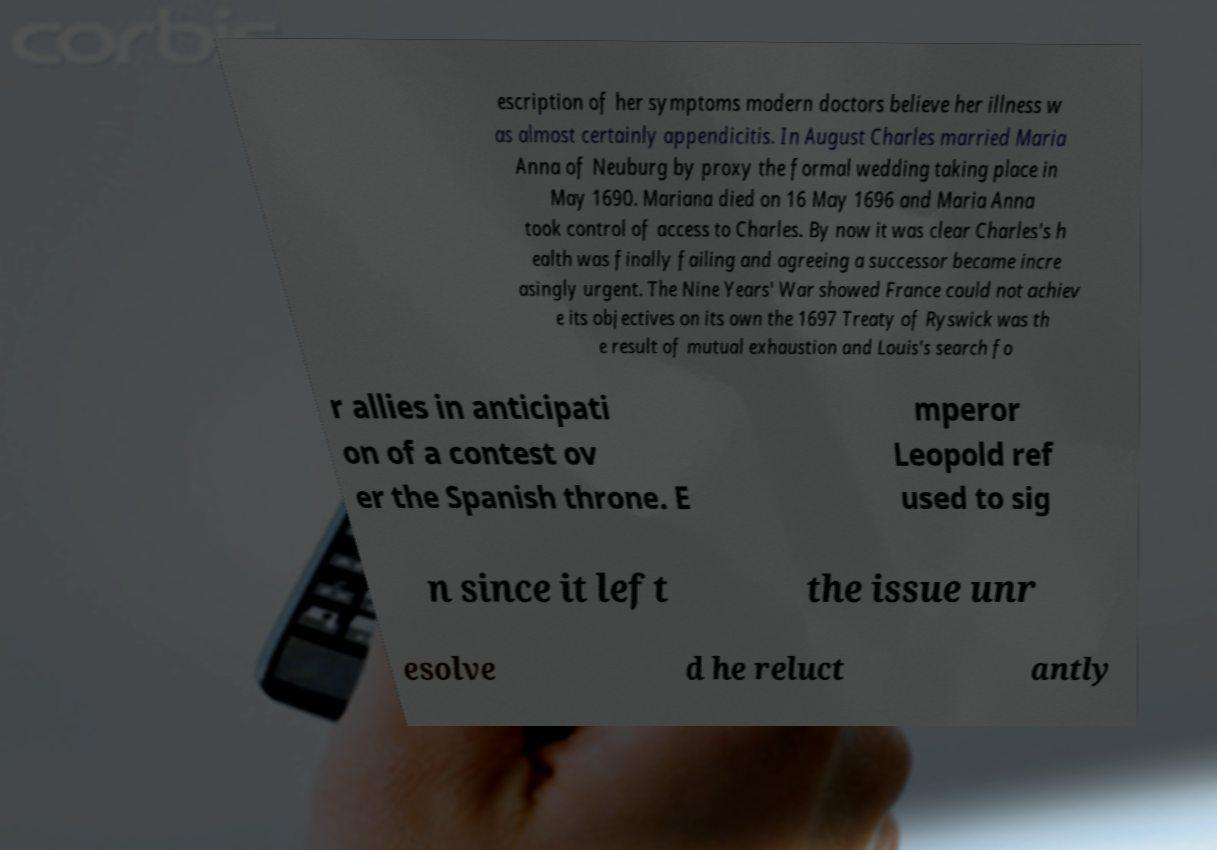Could you extract and type out the text from this image? escription of her symptoms modern doctors believe her illness w as almost certainly appendicitis. In August Charles married Maria Anna of Neuburg by proxy the formal wedding taking place in May 1690. Mariana died on 16 May 1696 and Maria Anna took control of access to Charles. By now it was clear Charles's h ealth was finally failing and agreeing a successor became incre asingly urgent. The Nine Years' War showed France could not achiev e its objectives on its own the 1697 Treaty of Ryswick was th e result of mutual exhaustion and Louis's search fo r allies in anticipati on of a contest ov er the Spanish throne. E mperor Leopold ref used to sig n since it left the issue unr esolve d he reluct antly 